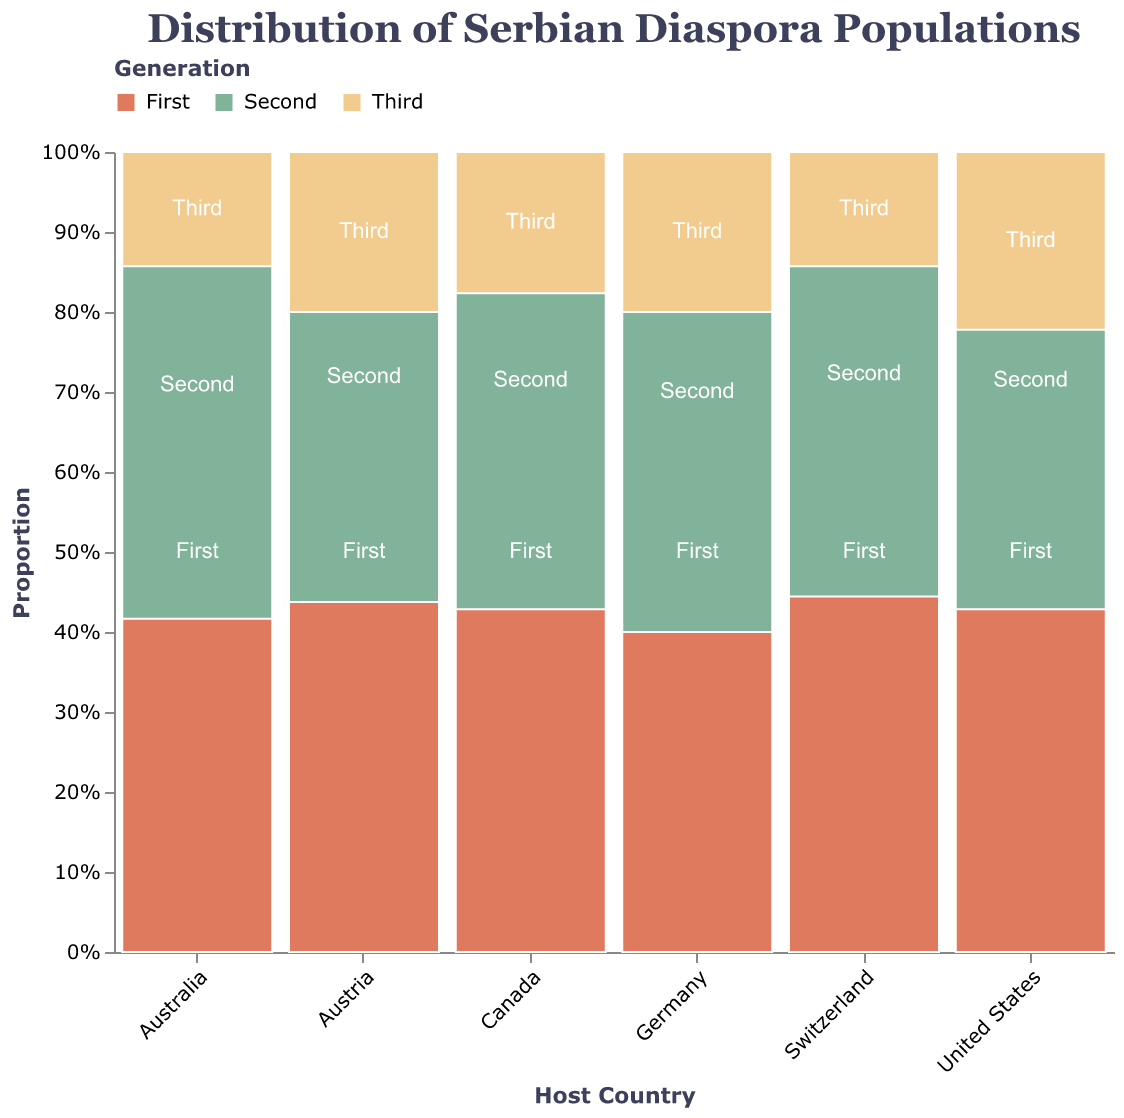Which country has the largest total Serbian diaspora population? To determine the country with the largest diaspora, sum the populations across all generations for each country and compare. The United States has the highest total with 150,000 (First) + 200,000 (Second) + 100,000 (Third) = 450,000.
Answer: United States What is the proportion of the First Generation Serbian population in Germany? Calculate the proportion of the First Generation population by dividing the First Generation population by the total population in Germany. This is 80,000 / (80,000 + 120,000 + 50,000) which equals approximately 0.32 (or 32%)
Answer: 32% Which generation has the lowest population in Australia? Compare the populations of the first, second, and third generations in Australia. The Third Generation has the least with 20,000.
Answer: Third What is the combined population of Second Generation Serbians in Germany and Austria? Add the Second Generation population in Germany (120,000) to that in Austria (90,000) to get the total. This is 120,000 + 90,000 = 210,000.
Answer: 210,000 Compare the proportion of Third Generation Serbians in Austria to that in Canada. Which is higher? Calculate the proportions for both Austria and Canada: Austria is 40,000 / (70,000 + 90,000 + 40,000) = 0.18 or 18%; Canada is 30,000 / (60,000 + 80,000 + 30,000) = 0.167 or 16.7%. Austria has the higher proportion.
Answer: Austria In which country is the gap between First and Third Generation populations the smallest? Calculate the differences between First and Third Generation populations for each country and identify the smallest gap. For the United States: 150,000 - 100,000 = 50,000, Germany: 80,000 - 50,000 = 30,000, Austria: 70,000 - 40,000 = 30,000, Canada: 60,000 - 30,000 = 30,000, Australia: 50,000 - 20,000 = 30,000, Switzerland: 40,000 - 15,000 = 25,000. Switzerland has the smallest gap.
Answer: Switzerland 